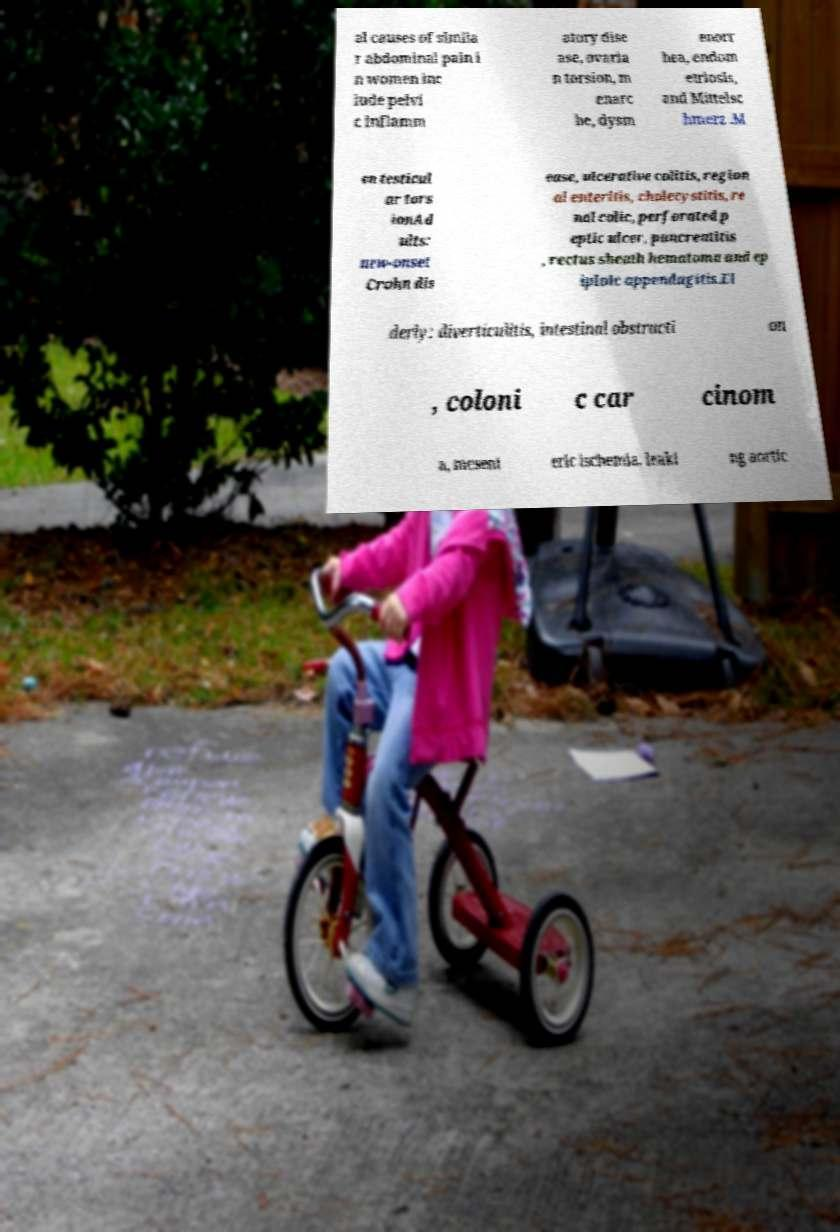I need the written content from this picture converted into text. Can you do that? al causes of simila r abdominal pain i n women inc lude pelvi c inflamm atory dise ase, ovaria n torsion, m enarc he, dysm enorr hea, endom etriosis, and Mittelsc hmerz .M en testicul ar tors ionAd ults: new-onset Crohn dis ease, ulcerative colitis, region al enteritis, cholecystitis, re nal colic, perforated p eptic ulcer, pancreatitis , rectus sheath hematoma and ep iploic appendagitis.El derly: diverticulitis, intestinal obstructi on , coloni c car cinom a, mesent eric ischemia, leaki ng aortic 